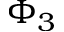Convert formula to latex. <formula><loc_0><loc_0><loc_500><loc_500>\Phi _ { 3 }</formula> 